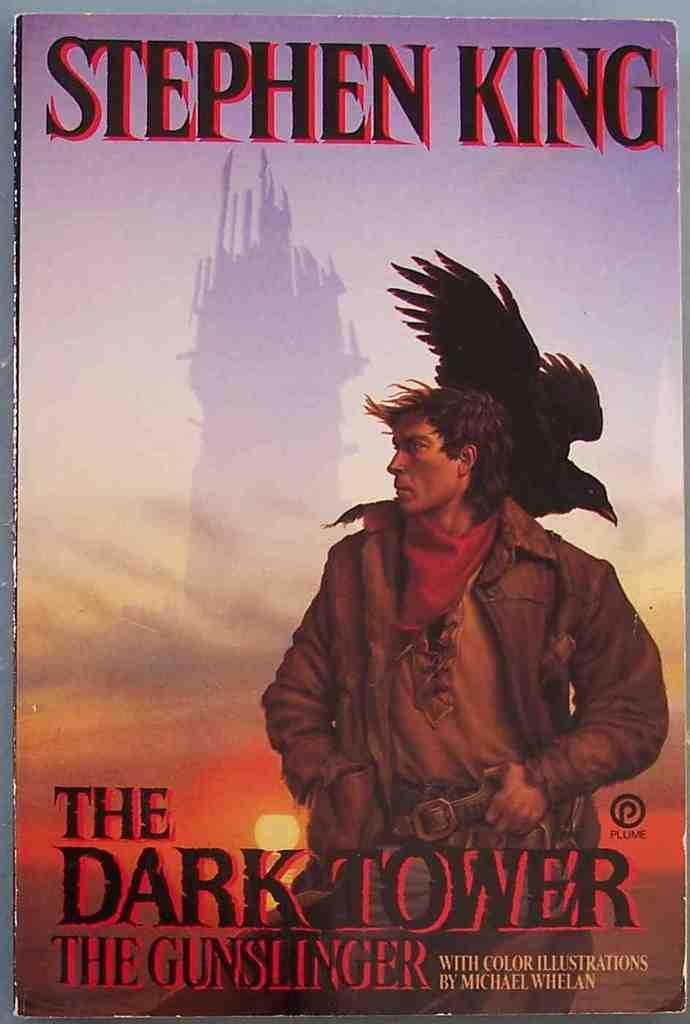Who is the author of this book?
Your response must be concise. Stephen king. What is the name of the book?
Make the answer very short. The dark tower the gunslinger. 